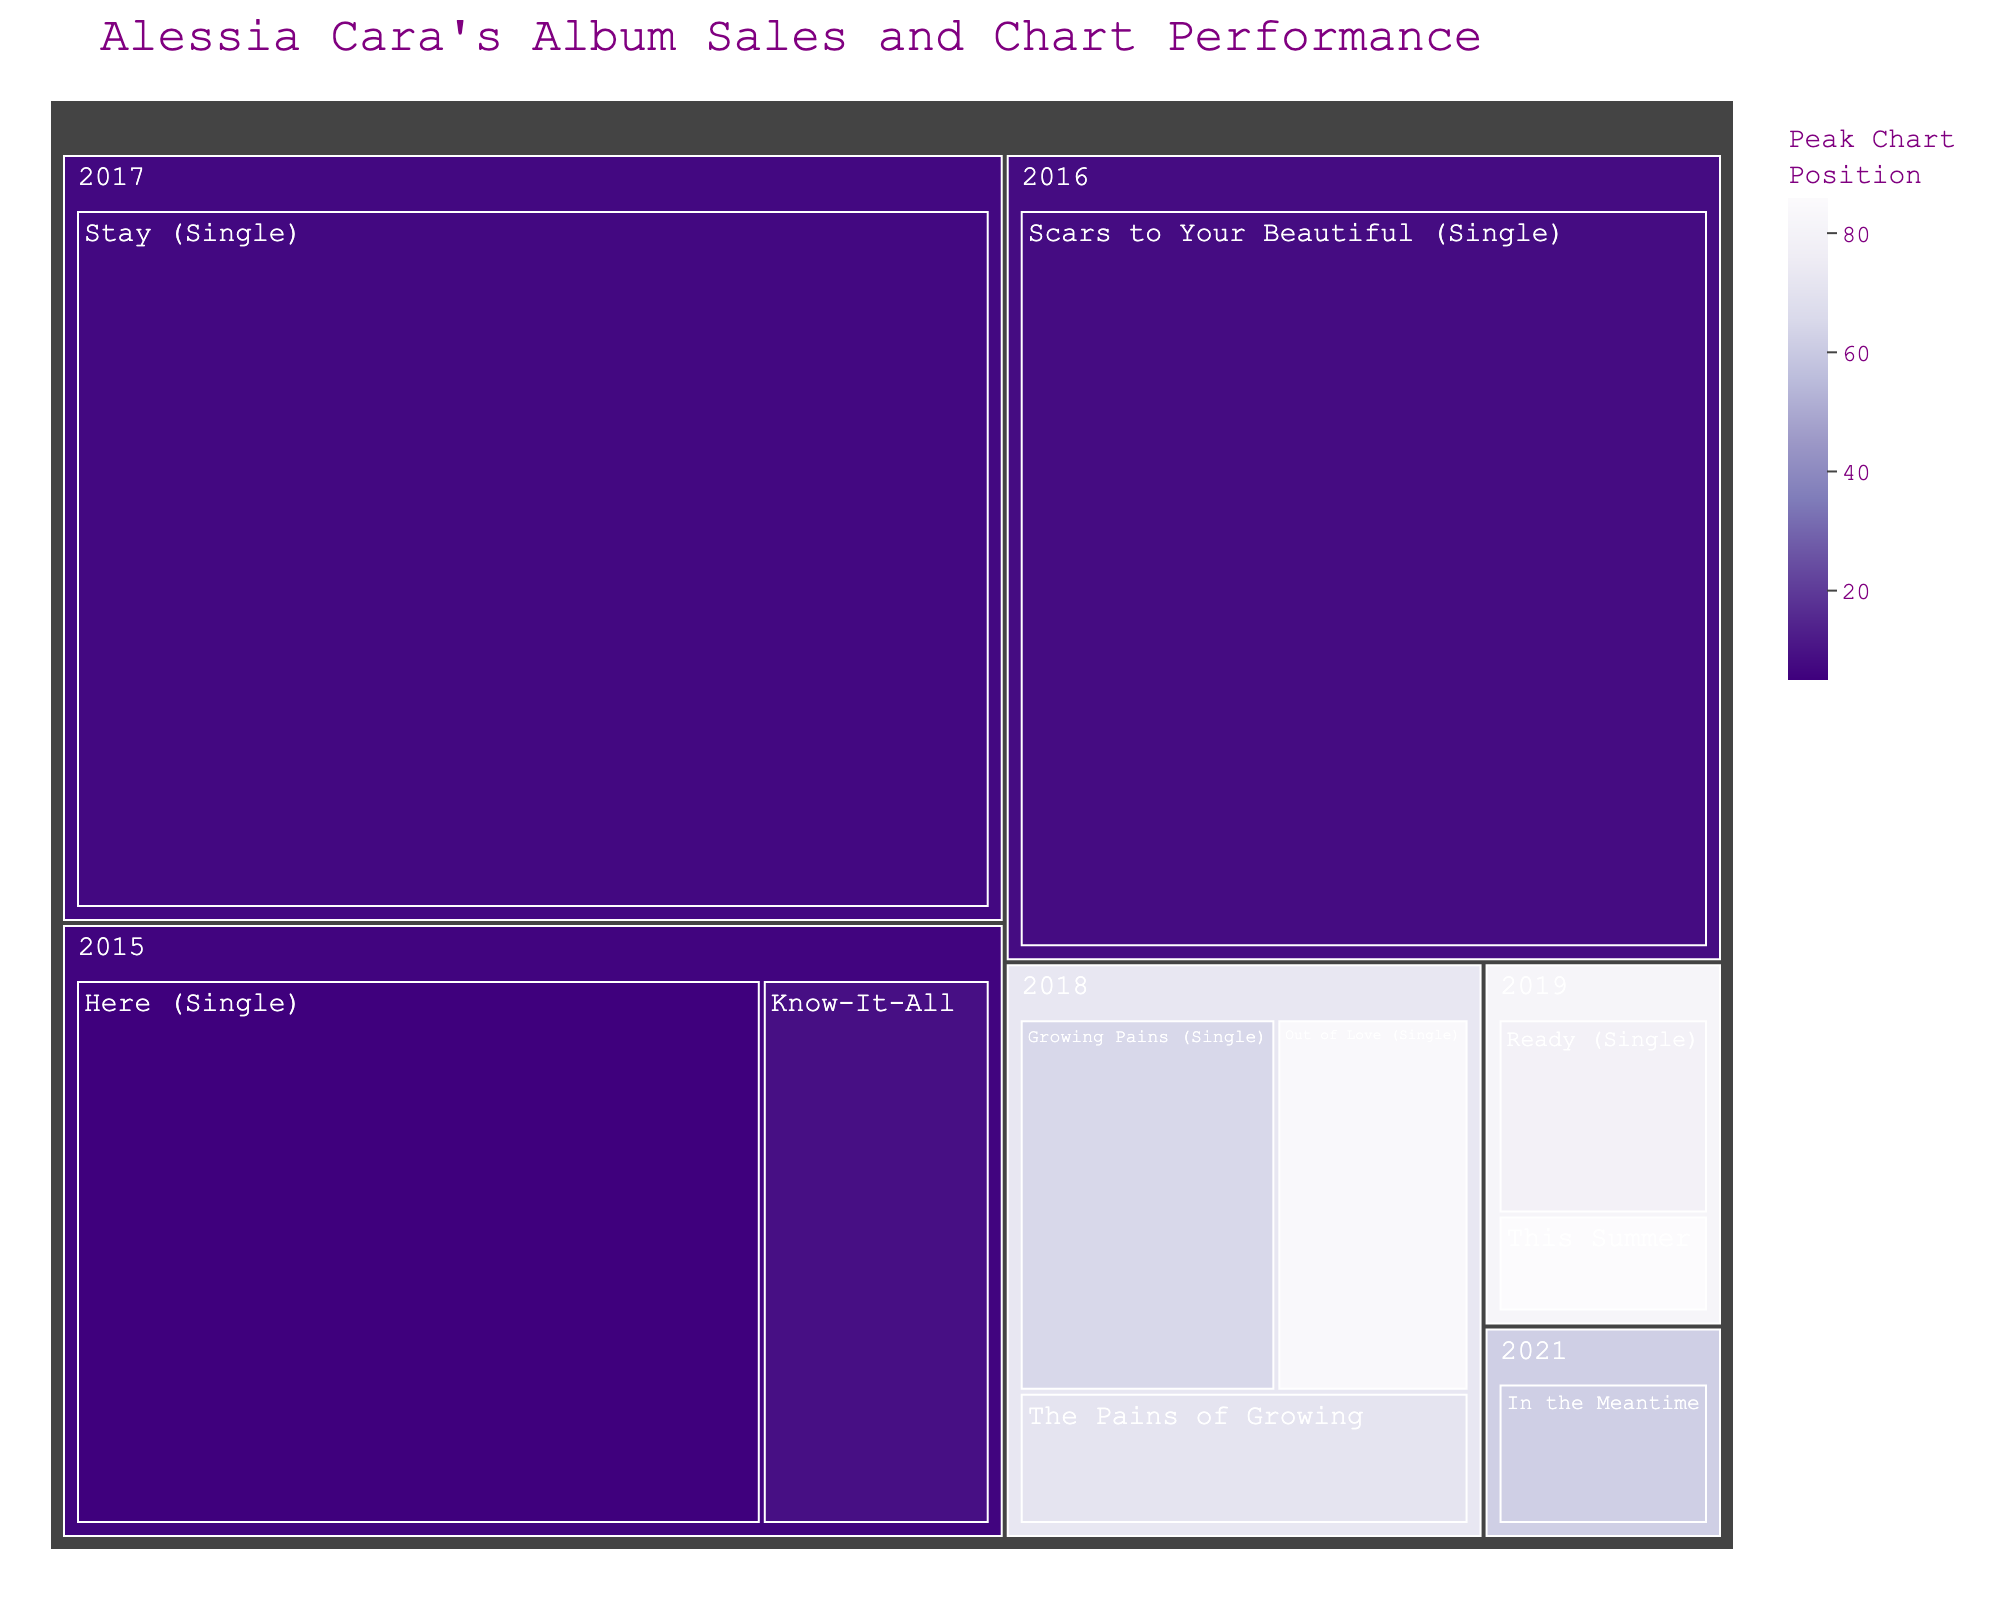What is the title of the figure? The title of the figure is usually displayed at the top of the visual representation. In this particular treemap, the title should succinctly describe the main theme of the data it represents.
Answer: Alessia Cara's Album Sales and Chart Performance How many albums and singles did Alessia Cara release in 2018? To find the number of albums and singles released in 2018, locate the section marked '2018' and count the individual items within this section.
Answer: 3 Which album has the highest sales according to the figure? To determine which album has the highest sales, look at the size of the rectangles in the treemap. The largest rectangle usually represents the highest sales.
Answer: Stay (Single) What is the peak chart position of the album "The Pains of Growing"? Find the section of the treemap labeled 'The Pains of Growing', and look at the hover data or the color that corresponds to the peak chart position.
Answer: 71 Which album released in 2019 had a higher peak chart position? Compare the peak chart positions of all the albums released in 2019 by looking at the hover data or color information for each 2019 album.
Answer: Ready (Single) What is the total sales volume of albums and singles released in 2017 and 2021 combined? Locate the sections for the years 2017 and 2021, then sum the sales of all albums and singles within those sections.
Answer: 5,350,000 Which album released in 2015 has the lower peak chart position, and what is it? Compare the peak chart positions of the albums released in 2015 by checking the color scale or hover data within the '2015' section. Identify the lower peak chart position and the album associated with it.
Answer: Know-It-All, 9 If you add up the sales for all albums released between 2018 and 2019, what is the total? Sum the sales figures for all albums released within the years 2018 and 2019. This involves adding the values for each album within both sections of the treemap.
Answer: 2,500,000 